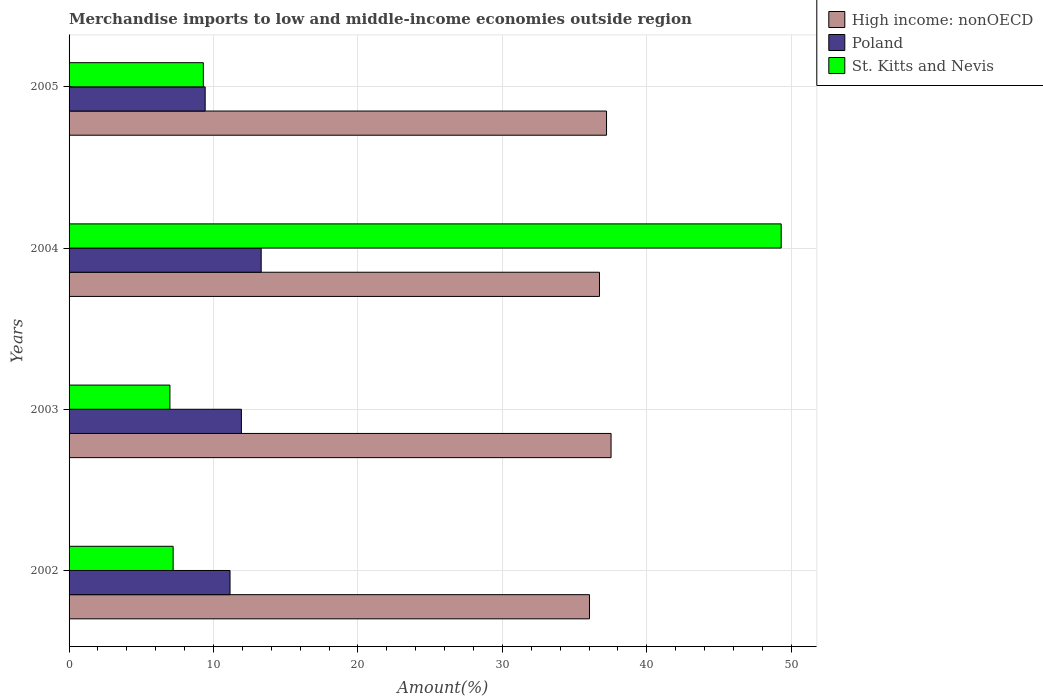How many different coloured bars are there?
Give a very brief answer. 3. How many groups of bars are there?
Make the answer very short. 4. How many bars are there on the 2nd tick from the bottom?
Offer a very short reply. 3. What is the label of the 4th group of bars from the top?
Keep it short and to the point. 2002. In how many cases, is the number of bars for a given year not equal to the number of legend labels?
Keep it short and to the point. 0. What is the percentage of amount earned from merchandise imports in High income: nonOECD in 2003?
Your response must be concise. 37.52. Across all years, what is the maximum percentage of amount earned from merchandise imports in High income: nonOECD?
Your answer should be compact. 37.52. Across all years, what is the minimum percentage of amount earned from merchandise imports in Poland?
Keep it short and to the point. 9.42. In which year was the percentage of amount earned from merchandise imports in Poland minimum?
Ensure brevity in your answer.  2005. What is the total percentage of amount earned from merchandise imports in High income: nonOECD in the graph?
Keep it short and to the point. 147.48. What is the difference between the percentage of amount earned from merchandise imports in Poland in 2002 and that in 2005?
Provide a short and direct response. 1.72. What is the difference between the percentage of amount earned from merchandise imports in High income: nonOECD in 2005 and the percentage of amount earned from merchandise imports in St. Kitts and Nevis in 2003?
Your answer should be very brief. 30.23. What is the average percentage of amount earned from merchandise imports in St. Kitts and Nevis per year?
Ensure brevity in your answer.  18.2. In the year 2003, what is the difference between the percentage of amount earned from merchandise imports in St. Kitts and Nevis and percentage of amount earned from merchandise imports in Poland?
Offer a very short reply. -4.95. What is the ratio of the percentage of amount earned from merchandise imports in St. Kitts and Nevis in 2004 to that in 2005?
Keep it short and to the point. 5.3. Is the difference between the percentage of amount earned from merchandise imports in St. Kitts and Nevis in 2002 and 2005 greater than the difference between the percentage of amount earned from merchandise imports in Poland in 2002 and 2005?
Make the answer very short. No. What is the difference between the highest and the second highest percentage of amount earned from merchandise imports in Poland?
Your response must be concise. 1.37. What is the difference between the highest and the lowest percentage of amount earned from merchandise imports in Poland?
Make the answer very short. 3.88. In how many years, is the percentage of amount earned from merchandise imports in St. Kitts and Nevis greater than the average percentage of amount earned from merchandise imports in St. Kitts and Nevis taken over all years?
Your answer should be very brief. 1. Is the sum of the percentage of amount earned from merchandise imports in High income: nonOECD in 2002 and 2005 greater than the maximum percentage of amount earned from merchandise imports in Poland across all years?
Your response must be concise. Yes. What does the 1st bar from the top in 2002 represents?
Give a very brief answer. St. Kitts and Nevis. What does the 1st bar from the bottom in 2005 represents?
Offer a terse response. High income: nonOECD. Is it the case that in every year, the sum of the percentage of amount earned from merchandise imports in Poland and percentage of amount earned from merchandise imports in St. Kitts and Nevis is greater than the percentage of amount earned from merchandise imports in High income: nonOECD?
Provide a short and direct response. No. Are all the bars in the graph horizontal?
Your answer should be very brief. Yes. What is the difference between two consecutive major ticks on the X-axis?
Your answer should be compact. 10. Are the values on the major ticks of X-axis written in scientific E-notation?
Ensure brevity in your answer.  No. Does the graph contain any zero values?
Keep it short and to the point. No. How many legend labels are there?
Provide a short and direct response. 3. What is the title of the graph?
Your answer should be compact. Merchandise imports to low and middle-income economies outside region. Does "Pakistan" appear as one of the legend labels in the graph?
Offer a terse response. No. What is the label or title of the X-axis?
Ensure brevity in your answer.  Amount(%). What is the Amount(%) in High income: nonOECD in 2002?
Your answer should be compact. 36.03. What is the Amount(%) in Poland in 2002?
Give a very brief answer. 11.14. What is the Amount(%) of St. Kitts and Nevis in 2002?
Your answer should be compact. 7.21. What is the Amount(%) in High income: nonOECD in 2003?
Your answer should be compact. 37.52. What is the Amount(%) of Poland in 2003?
Your response must be concise. 11.93. What is the Amount(%) of St. Kitts and Nevis in 2003?
Your answer should be compact. 6.98. What is the Amount(%) of High income: nonOECD in 2004?
Ensure brevity in your answer.  36.72. What is the Amount(%) in Poland in 2004?
Offer a very short reply. 13.3. What is the Amount(%) of St. Kitts and Nevis in 2004?
Your answer should be very brief. 49.3. What is the Amount(%) of High income: nonOECD in 2005?
Your answer should be very brief. 37.21. What is the Amount(%) in Poland in 2005?
Offer a terse response. 9.42. What is the Amount(%) in St. Kitts and Nevis in 2005?
Your response must be concise. 9.3. Across all years, what is the maximum Amount(%) in High income: nonOECD?
Your response must be concise. 37.52. Across all years, what is the maximum Amount(%) in Poland?
Offer a very short reply. 13.3. Across all years, what is the maximum Amount(%) in St. Kitts and Nevis?
Keep it short and to the point. 49.3. Across all years, what is the minimum Amount(%) of High income: nonOECD?
Make the answer very short. 36.03. Across all years, what is the minimum Amount(%) in Poland?
Keep it short and to the point. 9.42. Across all years, what is the minimum Amount(%) of St. Kitts and Nevis?
Provide a succinct answer. 6.98. What is the total Amount(%) in High income: nonOECD in the graph?
Your response must be concise. 147.48. What is the total Amount(%) in Poland in the graph?
Your response must be concise. 45.8. What is the total Amount(%) in St. Kitts and Nevis in the graph?
Provide a succinct answer. 72.78. What is the difference between the Amount(%) of High income: nonOECD in 2002 and that in 2003?
Make the answer very short. -1.49. What is the difference between the Amount(%) of Poland in 2002 and that in 2003?
Keep it short and to the point. -0.79. What is the difference between the Amount(%) in St. Kitts and Nevis in 2002 and that in 2003?
Ensure brevity in your answer.  0.22. What is the difference between the Amount(%) in High income: nonOECD in 2002 and that in 2004?
Make the answer very short. -0.69. What is the difference between the Amount(%) in Poland in 2002 and that in 2004?
Make the answer very short. -2.16. What is the difference between the Amount(%) in St. Kitts and Nevis in 2002 and that in 2004?
Your answer should be compact. -42.09. What is the difference between the Amount(%) in High income: nonOECD in 2002 and that in 2005?
Your response must be concise. -1.18. What is the difference between the Amount(%) in Poland in 2002 and that in 2005?
Offer a terse response. 1.72. What is the difference between the Amount(%) of St. Kitts and Nevis in 2002 and that in 2005?
Offer a terse response. -2.09. What is the difference between the Amount(%) in High income: nonOECD in 2003 and that in 2004?
Offer a terse response. 0.8. What is the difference between the Amount(%) of Poland in 2003 and that in 2004?
Your response must be concise. -1.37. What is the difference between the Amount(%) in St. Kitts and Nevis in 2003 and that in 2004?
Your answer should be very brief. -42.32. What is the difference between the Amount(%) of High income: nonOECD in 2003 and that in 2005?
Provide a succinct answer. 0.31. What is the difference between the Amount(%) in Poland in 2003 and that in 2005?
Make the answer very short. 2.51. What is the difference between the Amount(%) in St. Kitts and Nevis in 2003 and that in 2005?
Give a very brief answer. -2.31. What is the difference between the Amount(%) in High income: nonOECD in 2004 and that in 2005?
Your response must be concise. -0.49. What is the difference between the Amount(%) of Poland in 2004 and that in 2005?
Your answer should be very brief. 3.88. What is the difference between the Amount(%) in St. Kitts and Nevis in 2004 and that in 2005?
Offer a terse response. 40. What is the difference between the Amount(%) of High income: nonOECD in 2002 and the Amount(%) of Poland in 2003?
Give a very brief answer. 24.1. What is the difference between the Amount(%) in High income: nonOECD in 2002 and the Amount(%) in St. Kitts and Nevis in 2003?
Give a very brief answer. 29.05. What is the difference between the Amount(%) of Poland in 2002 and the Amount(%) of St. Kitts and Nevis in 2003?
Your answer should be compact. 4.16. What is the difference between the Amount(%) of High income: nonOECD in 2002 and the Amount(%) of Poland in 2004?
Provide a short and direct response. 22.73. What is the difference between the Amount(%) of High income: nonOECD in 2002 and the Amount(%) of St. Kitts and Nevis in 2004?
Keep it short and to the point. -13.27. What is the difference between the Amount(%) of Poland in 2002 and the Amount(%) of St. Kitts and Nevis in 2004?
Make the answer very short. -38.16. What is the difference between the Amount(%) of High income: nonOECD in 2002 and the Amount(%) of Poland in 2005?
Keep it short and to the point. 26.61. What is the difference between the Amount(%) of High income: nonOECD in 2002 and the Amount(%) of St. Kitts and Nevis in 2005?
Ensure brevity in your answer.  26.73. What is the difference between the Amount(%) in Poland in 2002 and the Amount(%) in St. Kitts and Nevis in 2005?
Provide a succinct answer. 1.85. What is the difference between the Amount(%) in High income: nonOECD in 2003 and the Amount(%) in Poland in 2004?
Offer a very short reply. 24.22. What is the difference between the Amount(%) in High income: nonOECD in 2003 and the Amount(%) in St. Kitts and Nevis in 2004?
Your response must be concise. -11.78. What is the difference between the Amount(%) in Poland in 2003 and the Amount(%) in St. Kitts and Nevis in 2004?
Keep it short and to the point. -37.37. What is the difference between the Amount(%) of High income: nonOECD in 2003 and the Amount(%) of Poland in 2005?
Keep it short and to the point. 28.1. What is the difference between the Amount(%) in High income: nonOECD in 2003 and the Amount(%) in St. Kitts and Nevis in 2005?
Keep it short and to the point. 28.23. What is the difference between the Amount(%) in Poland in 2003 and the Amount(%) in St. Kitts and Nevis in 2005?
Your response must be concise. 2.63. What is the difference between the Amount(%) of High income: nonOECD in 2004 and the Amount(%) of Poland in 2005?
Offer a terse response. 27.3. What is the difference between the Amount(%) in High income: nonOECD in 2004 and the Amount(%) in St. Kitts and Nevis in 2005?
Your answer should be very brief. 27.42. What is the difference between the Amount(%) in Poland in 2004 and the Amount(%) in St. Kitts and Nevis in 2005?
Your answer should be very brief. 4.01. What is the average Amount(%) in High income: nonOECD per year?
Ensure brevity in your answer.  36.87. What is the average Amount(%) in Poland per year?
Provide a succinct answer. 11.45. What is the average Amount(%) of St. Kitts and Nevis per year?
Give a very brief answer. 18.2. In the year 2002, what is the difference between the Amount(%) of High income: nonOECD and Amount(%) of Poland?
Offer a terse response. 24.89. In the year 2002, what is the difference between the Amount(%) of High income: nonOECD and Amount(%) of St. Kitts and Nevis?
Your response must be concise. 28.82. In the year 2002, what is the difference between the Amount(%) of Poland and Amount(%) of St. Kitts and Nevis?
Ensure brevity in your answer.  3.94. In the year 2003, what is the difference between the Amount(%) in High income: nonOECD and Amount(%) in Poland?
Ensure brevity in your answer.  25.59. In the year 2003, what is the difference between the Amount(%) in High income: nonOECD and Amount(%) in St. Kitts and Nevis?
Keep it short and to the point. 30.54. In the year 2003, what is the difference between the Amount(%) of Poland and Amount(%) of St. Kitts and Nevis?
Give a very brief answer. 4.95. In the year 2004, what is the difference between the Amount(%) of High income: nonOECD and Amount(%) of Poland?
Ensure brevity in your answer.  23.42. In the year 2004, what is the difference between the Amount(%) of High income: nonOECD and Amount(%) of St. Kitts and Nevis?
Provide a succinct answer. -12.58. In the year 2004, what is the difference between the Amount(%) in Poland and Amount(%) in St. Kitts and Nevis?
Provide a short and direct response. -36. In the year 2005, what is the difference between the Amount(%) in High income: nonOECD and Amount(%) in Poland?
Provide a short and direct response. 27.79. In the year 2005, what is the difference between the Amount(%) of High income: nonOECD and Amount(%) of St. Kitts and Nevis?
Your answer should be compact. 27.91. In the year 2005, what is the difference between the Amount(%) in Poland and Amount(%) in St. Kitts and Nevis?
Your response must be concise. 0.13. What is the ratio of the Amount(%) in High income: nonOECD in 2002 to that in 2003?
Keep it short and to the point. 0.96. What is the ratio of the Amount(%) of Poland in 2002 to that in 2003?
Provide a succinct answer. 0.93. What is the ratio of the Amount(%) of St. Kitts and Nevis in 2002 to that in 2003?
Give a very brief answer. 1.03. What is the ratio of the Amount(%) in High income: nonOECD in 2002 to that in 2004?
Your answer should be very brief. 0.98. What is the ratio of the Amount(%) in Poland in 2002 to that in 2004?
Offer a terse response. 0.84. What is the ratio of the Amount(%) in St. Kitts and Nevis in 2002 to that in 2004?
Provide a succinct answer. 0.15. What is the ratio of the Amount(%) of High income: nonOECD in 2002 to that in 2005?
Provide a short and direct response. 0.97. What is the ratio of the Amount(%) of Poland in 2002 to that in 2005?
Ensure brevity in your answer.  1.18. What is the ratio of the Amount(%) of St. Kitts and Nevis in 2002 to that in 2005?
Provide a short and direct response. 0.78. What is the ratio of the Amount(%) of High income: nonOECD in 2003 to that in 2004?
Offer a terse response. 1.02. What is the ratio of the Amount(%) of Poland in 2003 to that in 2004?
Provide a succinct answer. 0.9. What is the ratio of the Amount(%) of St. Kitts and Nevis in 2003 to that in 2004?
Offer a terse response. 0.14. What is the ratio of the Amount(%) of High income: nonOECD in 2003 to that in 2005?
Provide a succinct answer. 1.01. What is the ratio of the Amount(%) of Poland in 2003 to that in 2005?
Give a very brief answer. 1.27. What is the ratio of the Amount(%) in St. Kitts and Nevis in 2003 to that in 2005?
Give a very brief answer. 0.75. What is the ratio of the Amount(%) in High income: nonOECD in 2004 to that in 2005?
Keep it short and to the point. 0.99. What is the ratio of the Amount(%) in Poland in 2004 to that in 2005?
Your response must be concise. 1.41. What is the ratio of the Amount(%) of St. Kitts and Nevis in 2004 to that in 2005?
Make the answer very short. 5.3. What is the difference between the highest and the second highest Amount(%) in High income: nonOECD?
Ensure brevity in your answer.  0.31. What is the difference between the highest and the second highest Amount(%) of Poland?
Your response must be concise. 1.37. What is the difference between the highest and the second highest Amount(%) of St. Kitts and Nevis?
Give a very brief answer. 40. What is the difference between the highest and the lowest Amount(%) of High income: nonOECD?
Give a very brief answer. 1.49. What is the difference between the highest and the lowest Amount(%) in Poland?
Your answer should be compact. 3.88. What is the difference between the highest and the lowest Amount(%) in St. Kitts and Nevis?
Provide a short and direct response. 42.32. 